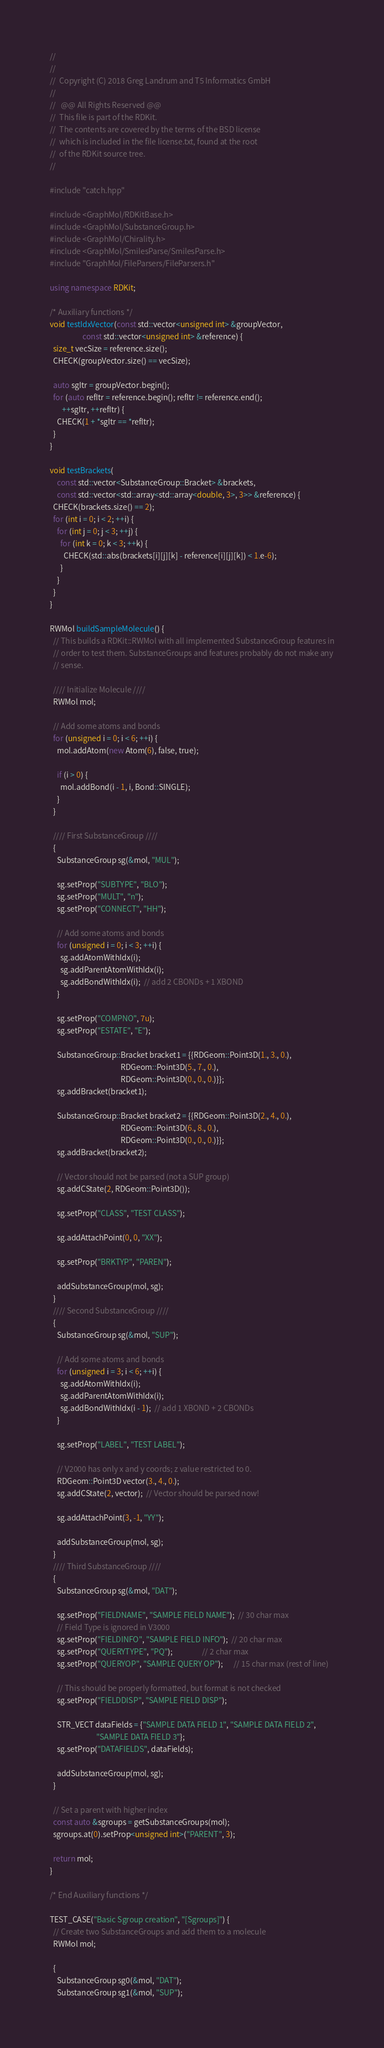Convert code to text. <code><loc_0><loc_0><loc_500><loc_500><_C++_>//
//
//  Copyright (C) 2018 Greg Landrum and T5 Informatics GmbH
//
//   @@ All Rights Reserved @@
//  This file is part of the RDKit.
//  The contents are covered by the terms of the BSD license
//  which is included in the file license.txt, found at the root
//  of the RDKit source tree.
//

#include "catch.hpp"

#include <GraphMol/RDKitBase.h>
#include <GraphMol/SubstanceGroup.h>
#include <GraphMol/Chirality.h>
#include <GraphMol/SmilesParse/SmilesParse.h>
#include "GraphMol/FileParsers/FileParsers.h"

using namespace RDKit;

/* Auxiliary functions */
void testIdxVector(const std::vector<unsigned int> &groupVector,
                   const std::vector<unsigned int> &reference) {
  size_t vecSize = reference.size();
  CHECK(groupVector.size() == vecSize);

  auto sgItr = groupVector.begin();
  for (auto refItr = reference.begin(); refItr != reference.end();
       ++sgItr, ++refItr) {
    CHECK(1 + *sgItr == *refItr);
  }
}

void testBrackets(
    const std::vector<SubstanceGroup::Bracket> &brackets,
    const std::vector<std::array<std::array<double, 3>, 3>> &reference) {
  CHECK(brackets.size() == 2);
  for (int i = 0; i < 2; ++i) {
    for (int j = 0; j < 3; ++j) {
      for (int k = 0; k < 3; ++k) {
        CHECK(std::abs(brackets[i][j][k] - reference[i][j][k]) < 1.e-6);
      }
    }
  }
}

RWMol buildSampleMolecule() {
  // This builds a RDKit::RWMol with all implemented SubstanceGroup features in
  // order to test them. SubstanceGroups and features probably do not make any
  // sense.

  //// Initialize Molecule ////
  RWMol mol;

  // Add some atoms and bonds
  for (unsigned i = 0; i < 6; ++i) {
    mol.addAtom(new Atom(6), false, true);

    if (i > 0) {
      mol.addBond(i - 1, i, Bond::SINGLE);
    }
  }

  //// First SubstanceGroup ////
  {
    SubstanceGroup sg(&mol, "MUL");

    sg.setProp("SUBTYPE", "BLO");
    sg.setProp("MULT", "n");
    sg.setProp("CONNECT", "HH");

    // Add some atoms and bonds
    for (unsigned i = 0; i < 3; ++i) {
      sg.addAtomWithIdx(i);
      sg.addParentAtomWithIdx(i);
      sg.addBondWithIdx(i);  // add 2 CBONDs + 1 XBOND
    }

    sg.setProp("COMPNO", 7u);
    sg.setProp("ESTATE", "E");

    SubstanceGroup::Bracket bracket1 = {{RDGeom::Point3D(1., 3., 0.),
                                         RDGeom::Point3D(5., 7., 0.),
                                         RDGeom::Point3D(0., 0., 0.)}};
    sg.addBracket(bracket1);

    SubstanceGroup::Bracket bracket2 = {{RDGeom::Point3D(2., 4., 0.),
                                         RDGeom::Point3D(6., 8., 0.),
                                         RDGeom::Point3D(0., 0., 0.)}};
    sg.addBracket(bracket2);

    // Vector should not be parsed (not a SUP group)
    sg.addCState(2, RDGeom::Point3D());

    sg.setProp("CLASS", "TEST CLASS");

    sg.addAttachPoint(0, 0, "XX");

    sg.setProp("BRKTYP", "PAREN");

    addSubstanceGroup(mol, sg);
  }
  //// Second SubstanceGroup ////
  {
    SubstanceGroup sg(&mol, "SUP");

    // Add some atoms and bonds
    for (unsigned i = 3; i < 6; ++i) {
      sg.addAtomWithIdx(i);
      sg.addParentAtomWithIdx(i);
      sg.addBondWithIdx(i - 1);  // add 1 XBOND + 2 CBONDs
    }

    sg.setProp("LABEL", "TEST LABEL");

    // V2000 has only x and y coords; z value restricted to 0.
    RDGeom::Point3D vector(3., 4., 0.);
    sg.addCState(2, vector);  // Vector should be parsed now!

    sg.addAttachPoint(3, -1, "YY");

    addSubstanceGroup(mol, sg);
  }
  //// Third SubstanceGroup ////
  {
    SubstanceGroup sg(&mol, "DAT");

    sg.setProp("FIELDNAME", "SAMPLE FIELD NAME");  // 30 char max
    // Field Type is ignored in V3000
    sg.setProp("FIELDINFO", "SAMPLE FIELD INFO");  // 20 char max
    sg.setProp("QUERYTYPE", "PQ");                 // 2 char max
    sg.setProp("QUERYOP", "SAMPLE QUERY OP");      // 15 char max (rest of line)

    // This should be properly formatted, but format is not checked
    sg.setProp("FIELDDISP", "SAMPLE FIELD DISP");

    STR_VECT dataFields = {"SAMPLE DATA FIELD 1", "SAMPLE DATA FIELD 2",
                           "SAMPLE DATA FIELD 3"};
    sg.setProp("DATAFIELDS", dataFields);

    addSubstanceGroup(mol, sg);
  }

  // Set a parent with higher index
  const auto &sgroups = getSubstanceGroups(mol);
  sgroups.at(0).setProp<unsigned int>("PARENT", 3);

  return mol;
}

/* End Auxiliary functions */

TEST_CASE("Basic Sgroup creation", "[Sgroups]") {
  // Create two SubstanceGroups and add them to a molecule
  RWMol mol;

  {
    SubstanceGroup sg0(&mol, "DAT");
    SubstanceGroup sg1(&mol, "SUP");</code> 